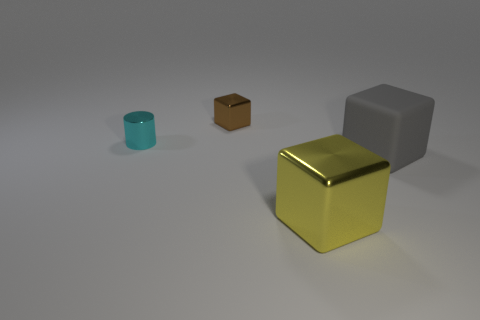Add 1 big blue balls. How many objects exist? 5 Subtract all cylinders. How many objects are left? 3 Subtract all large gray matte objects. Subtract all tiny cylinders. How many objects are left? 2 Add 2 gray rubber blocks. How many gray rubber blocks are left? 3 Add 1 blue shiny spheres. How many blue shiny spheres exist? 1 Subtract 0 yellow cylinders. How many objects are left? 4 